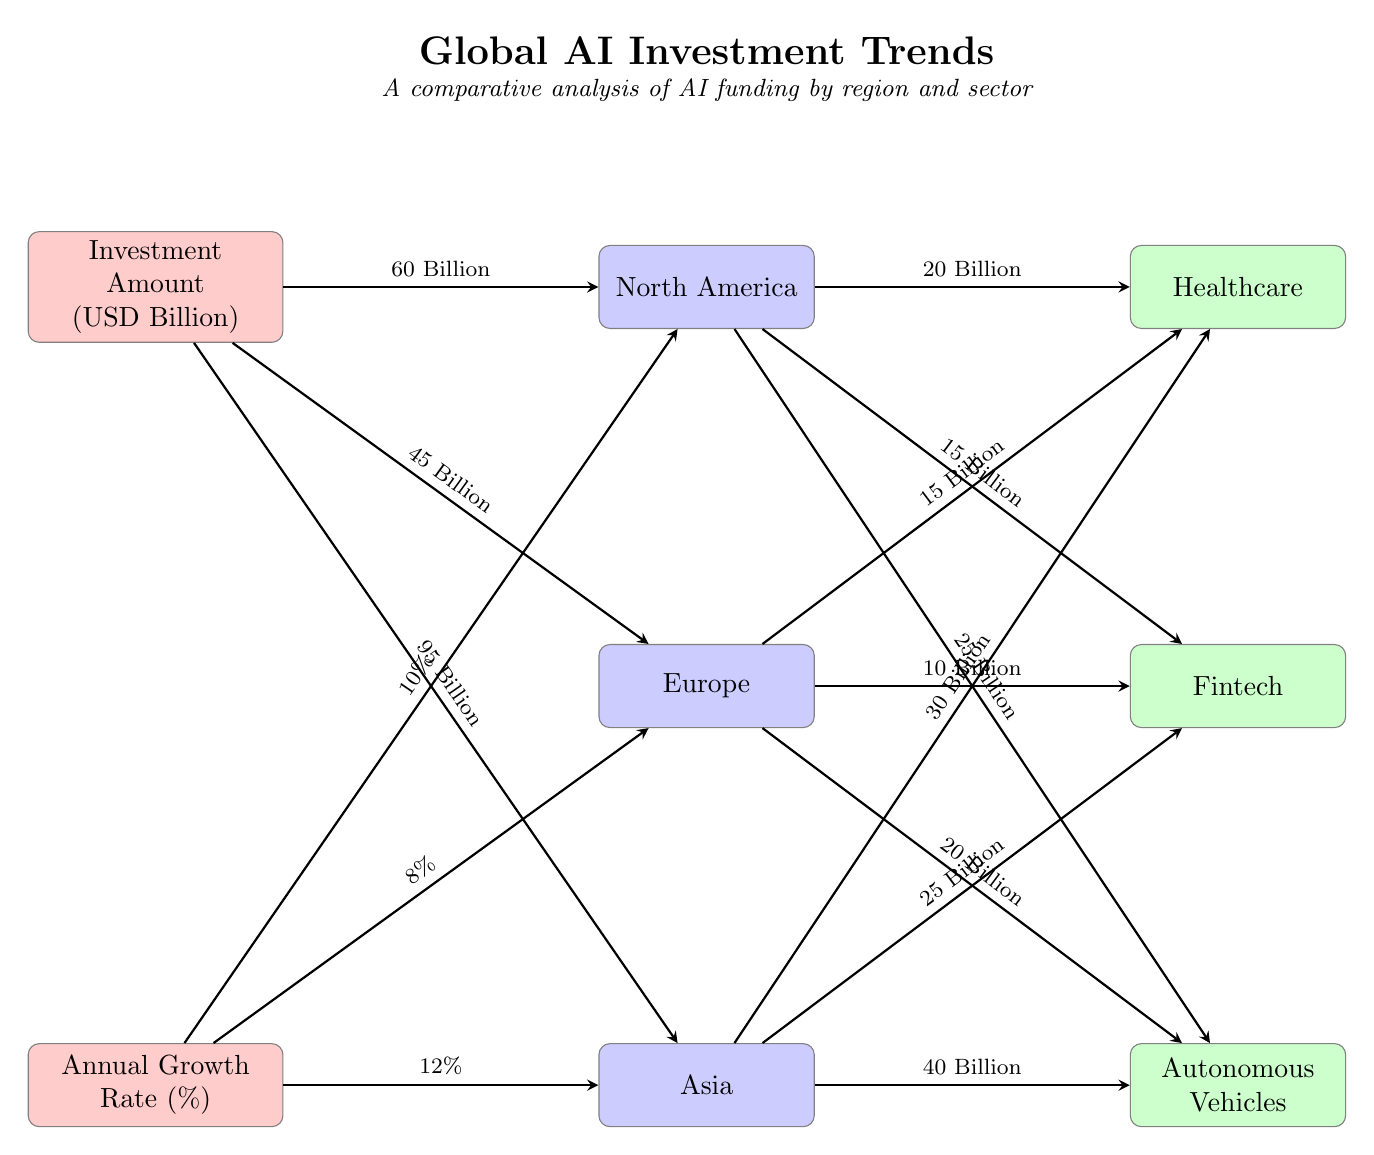What is the total investment amount for Healthcare in North America? The arrow from North America to Healthcare indicates an investment amount of 20 Billion USD as labeled in the diagram.
Answer: 20 Billion What is the annual growth rate of AI investment in Asia? The arrow connecting Asia to the Annual Growth Rate node shows an annual growth rate of 12%, which is indicated directly in the diagram.
Answer: 12% Which region has the highest investment amount in Autonomous Vehicles? By comparing the arrows leading to Autonomous Vehicles, Asia has the highest investment of 40 Billion USD. This is from the Asia node, which is directly connected with an arrow.
Answer: Asia How much funding does Europe receive for Fintech? The diagram displays an arrow linking Europe to Fintech that shows a funding amount of 10 Billion USD, making it straightforward to extract this value.
Answer: 10 Billion Which sector receives the lowest funding in North America? When reviewing the funding amounts for North America, Fintech with a funding of 15 Billion USD is lower than Healthcare (20 Billion) and Autonomous Vehicles (25 Billion), making it the lowest for that region.
Answer: Fintech Combined funding for Healthcare across all regions equals what amount? The total can be calculated by adding the funding amounts from each region: North America (20 Billion) + Europe (15 Billion) + Asia (30 Billion), which totals to 65 Billion USD.
Answer: 65 Billion Which region has the largest total investment amount in AI? Looking at the investment amounts from each region: North America (60 Billion), Europe (45 Billion), and Asia (95 Billion), Asia has the largest total investment amount as indicated by the connecting arrows in the diagram.
Answer: Asia Which sector shows the highest investment growth rate and what is that rate? Analyzing the gravity factors, Asia has the highest growth rate of 12% in the diagram while sector funding depicted by arrows indicates high funding amounts, with no explicit growth rate comparison between sectors but leaning on sector funding, the autonomous vehicles show a broader funding.
Answer: 12% 